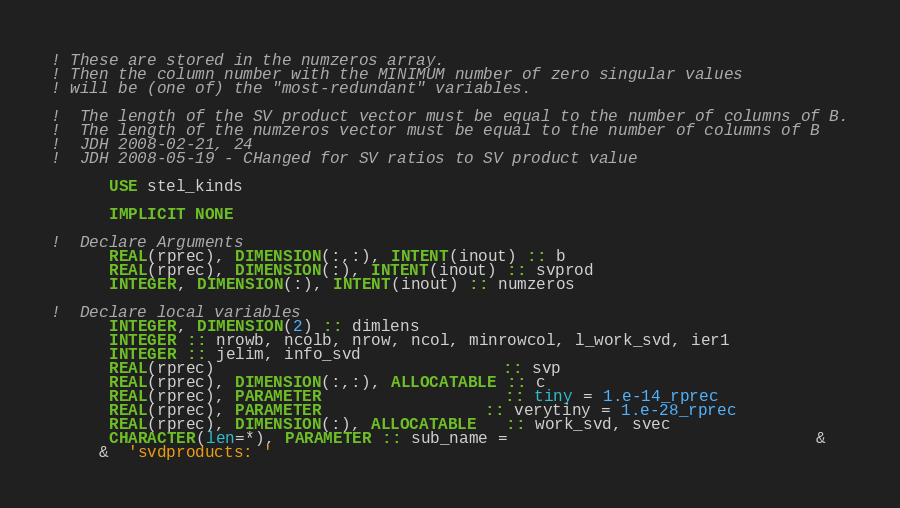<code> <loc_0><loc_0><loc_500><loc_500><_FORTRAN_>! These are stored in the numzeros array.
! Then the column number with the MINIMUM number of zero singular values
! will be (one of) the "most-redundant" variables.

!  The length of the SV product vector must be equal to the number of columns of B.
!  The length of the numzeros vector must be equal to the number of columns of B
!  JDH 2008-02-21, 24
!  JDH 2008-05-19 - CHanged for SV ratios to SV product value

      USE stel_kinds
      
      IMPLICIT NONE

!  Declare Arguments
      REAL(rprec), DIMENSION(:,:), INTENT(inout) :: b
      REAL(rprec), DIMENSION(:), INTENT(inout) :: svprod
      INTEGER, DIMENSION(:), INTENT(inout) :: numzeros

!  Declare local variables
      INTEGER, DIMENSION(2) :: dimlens
      INTEGER :: nrowb, ncolb, nrow, ncol, minrowcol, l_work_svd, ier1 
      INTEGER :: jelim, info_svd
      REAL(rprec)                              :: svp
      REAL(rprec), DIMENSION(:,:), ALLOCATABLE :: c
      REAL(rprec), PARAMETER                   :: tiny = 1.e-14_rprec
      REAL(rprec), PARAMETER                 :: verytiny = 1.e-28_rprec
      REAL(rprec), DIMENSION(:), ALLOCATABLE   :: work_svd, svec
      CHARACTER(len=*), PARAMETER :: sub_name =                                &
     &  'svdproducts: '
</code> 